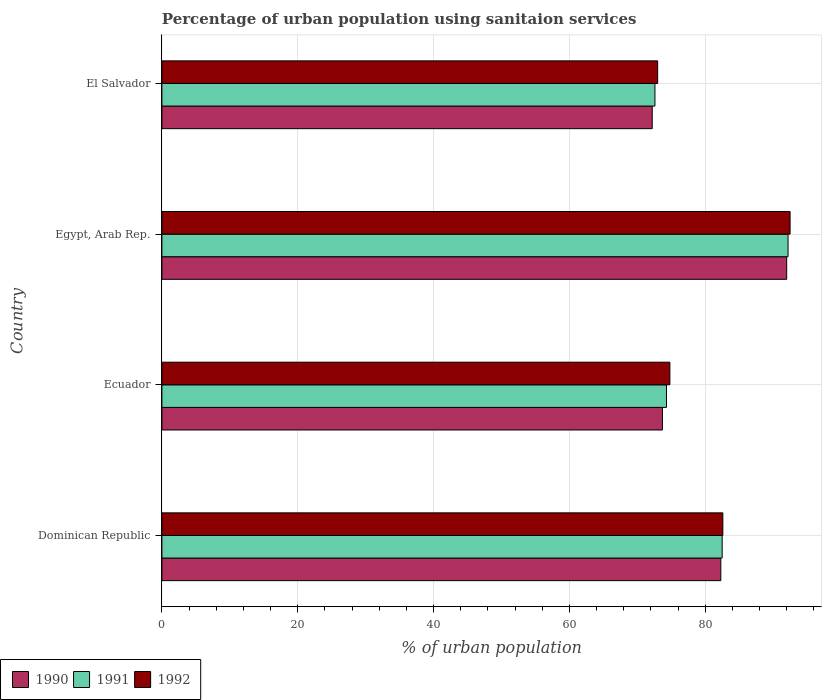How many bars are there on the 2nd tick from the bottom?
Your answer should be compact. 3. What is the label of the 4th group of bars from the top?
Offer a very short reply. Dominican Republic. What is the percentage of urban population using sanitaion services in 1992 in Egypt, Arab Rep.?
Ensure brevity in your answer.  92.5. Across all countries, what is the maximum percentage of urban population using sanitaion services in 1992?
Provide a succinct answer. 92.5. Across all countries, what is the minimum percentage of urban population using sanitaion services in 1990?
Make the answer very short. 72.2. In which country was the percentage of urban population using sanitaion services in 1992 maximum?
Offer a very short reply. Egypt, Arab Rep. In which country was the percentage of urban population using sanitaion services in 1992 minimum?
Your answer should be very brief. El Salvador. What is the total percentage of urban population using sanitaion services in 1991 in the graph?
Ensure brevity in your answer.  321.6. What is the difference between the percentage of urban population using sanitaion services in 1992 in Dominican Republic and that in Ecuador?
Ensure brevity in your answer.  7.8. What is the difference between the percentage of urban population using sanitaion services in 1990 in El Salvador and the percentage of urban population using sanitaion services in 1992 in Egypt, Arab Rep.?
Offer a very short reply. -20.3. What is the average percentage of urban population using sanitaion services in 1992 per country?
Your answer should be very brief. 80.72. What is the difference between the percentage of urban population using sanitaion services in 1991 and percentage of urban population using sanitaion services in 1990 in El Salvador?
Provide a succinct answer. 0.4. In how many countries, is the percentage of urban population using sanitaion services in 1992 greater than 28 %?
Provide a short and direct response. 4. What is the ratio of the percentage of urban population using sanitaion services in 1991 in Dominican Republic to that in Ecuador?
Your response must be concise. 1.11. What is the difference between the highest and the second highest percentage of urban population using sanitaion services in 1990?
Make the answer very short. 9.7. What is the difference between the highest and the lowest percentage of urban population using sanitaion services in 1992?
Offer a very short reply. 19.5. Is the sum of the percentage of urban population using sanitaion services in 1990 in Dominican Republic and Ecuador greater than the maximum percentage of urban population using sanitaion services in 1992 across all countries?
Your response must be concise. Yes. What does the 3rd bar from the bottom in El Salvador represents?
Give a very brief answer. 1992. Is it the case that in every country, the sum of the percentage of urban population using sanitaion services in 1990 and percentage of urban population using sanitaion services in 1992 is greater than the percentage of urban population using sanitaion services in 1991?
Provide a succinct answer. Yes. How many bars are there?
Your response must be concise. 12. What is the difference between two consecutive major ticks on the X-axis?
Your answer should be compact. 20. Are the values on the major ticks of X-axis written in scientific E-notation?
Make the answer very short. No. Where does the legend appear in the graph?
Your answer should be compact. Bottom left. How many legend labels are there?
Offer a very short reply. 3. What is the title of the graph?
Make the answer very short. Percentage of urban population using sanitaion services. Does "2007" appear as one of the legend labels in the graph?
Offer a terse response. No. What is the label or title of the X-axis?
Offer a terse response. % of urban population. What is the label or title of the Y-axis?
Your answer should be compact. Country. What is the % of urban population of 1990 in Dominican Republic?
Your answer should be very brief. 82.3. What is the % of urban population of 1991 in Dominican Republic?
Ensure brevity in your answer.  82.5. What is the % of urban population in 1992 in Dominican Republic?
Make the answer very short. 82.6. What is the % of urban population of 1990 in Ecuador?
Keep it short and to the point. 73.7. What is the % of urban population of 1991 in Ecuador?
Ensure brevity in your answer.  74.3. What is the % of urban population of 1992 in Ecuador?
Give a very brief answer. 74.8. What is the % of urban population in 1990 in Egypt, Arab Rep.?
Keep it short and to the point. 92. What is the % of urban population of 1991 in Egypt, Arab Rep.?
Keep it short and to the point. 92.2. What is the % of urban population in 1992 in Egypt, Arab Rep.?
Give a very brief answer. 92.5. What is the % of urban population of 1990 in El Salvador?
Give a very brief answer. 72.2. What is the % of urban population of 1991 in El Salvador?
Keep it short and to the point. 72.6. Across all countries, what is the maximum % of urban population in 1990?
Your answer should be very brief. 92. Across all countries, what is the maximum % of urban population of 1991?
Provide a succinct answer. 92.2. Across all countries, what is the maximum % of urban population in 1992?
Make the answer very short. 92.5. Across all countries, what is the minimum % of urban population of 1990?
Keep it short and to the point. 72.2. Across all countries, what is the minimum % of urban population in 1991?
Make the answer very short. 72.6. What is the total % of urban population of 1990 in the graph?
Your answer should be very brief. 320.2. What is the total % of urban population in 1991 in the graph?
Make the answer very short. 321.6. What is the total % of urban population of 1992 in the graph?
Your answer should be compact. 322.9. What is the difference between the % of urban population of 1991 in Dominican Republic and that in Ecuador?
Ensure brevity in your answer.  8.2. What is the difference between the % of urban population of 1990 in Dominican Republic and that in Egypt, Arab Rep.?
Your answer should be very brief. -9.7. What is the difference between the % of urban population of 1990 in Dominican Republic and that in El Salvador?
Ensure brevity in your answer.  10.1. What is the difference between the % of urban population of 1991 in Dominican Republic and that in El Salvador?
Make the answer very short. 9.9. What is the difference between the % of urban population of 1992 in Dominican Republic and that in El Salvador?
Offer a very short reply. 9.6. What is the difference between the % of urban population in 1990 in Ecuador and that in Egypt, Arab Rep.?
Give a very brief answer. -18.3. What is the difference between the % of urban population in 1991 in Ecuador and that in Egypt, Arab Rep.?
Provide a succinct answer. -17.9. What is the difference between the % of urban population of 1992 in Ecuador and that in Egypt, Arab Rep.?
Give a very brief answer. -17.7. What is the difference between the % of urban population in 1990 in Ecuador and that in El Salvador?
Give a very brief answer. 1.5. What is the difference between the % of urban population in 1990 in Egypt, Arab Rep. and that in El Salvador?
Offer a very short reply. 19.8. What is the difference between the % of urban population of 1991 in Egypt, Arab Rep. and that in El Salvador?
Keep it short and to the point. 19.6. What is the difference between the % of urban population in 1992 in Egypt, Arab Rep. and that in El Salvador?
Your answer should be compact. 19.5. What is the difference between the % of urban population in 1990 in Dominican Republic and the % of urban population in 1991 in Ecuador?
Offer a very short reply. 8. What is the difference between the % of urban population in 1990 in Dominican Republic and the % of urban population in 1992 in Ecuador?
Your response must be concise. 7.5. What is the difference between the % of urban population of 1991 in Dominican Republic and the % of urban population of 1992 in Ecuador?
Give a very brief answer. 7.7. What is the difference between the % of urban population of 1990 in Dominican Republic and the % of urban population of 1991 in Egypt, Arab Rep.?
Make the answer very short. -9.9. What is the difference between the % of urban population in 1991 in Dominican Republic and the % of urban population in 1992 in Egypt, Arab Rep.?
Offer a very short reply. -10. What is the difference between the % of urban population in 1990 in Dominican Republic and the % of urban population in 1992 in El Salvador?
Ensure brevity in your answer.  9.3. What is the difference between the % of urban population of 1990 in Ecuador and the % of urban population of 1991 in Egypt, Arab Rep.?
Make the answer very short. -18.5. What is the difference between the % of urban population of 1990 in Ecuador and the % of urban population of 1992 in Egypt, Arab Rep.?
Ensure brevity in your answer.  -18.8. What is the difference between the % of urban population of 1991 in Ecuador and the % of urban population of 1992 in Egypt, Arab Rep.?
Provide a succinct answer. -18.2. What is the difference between the % of urban population of 1991 in Ecuador and the % of urban population of 1992 in El Salvador?
Provide a succinct answer. 1.3. What is the difference between the % of urban population in 1990 in Egypt, Arab Rep. and the % of urban population in 1991 in El Salvador?
Your response must be concise. 19.4. What is the difference between the % of urban population in 1991 in Egypt, Arab Rep. and the % of urban population in 1992 in El Salvador?
Offer a very short reply. 19.2. What is the average % of urban population in 1990 per country?
Offer a very short reply. 80.05. What is the average % of urban population of 1991 per country?
Keep it short and to the point. 80.4. What is the average % of urban population of 1992 per country?
Your answer should be very brief. 80.72. What is the difference between the % of urban population of 1990 and % of urban population of 1991 in Dominican Republic?
Your answer should be compact. -0.2. What is the difference between the % of urban population in 1991 and % of urban population in 1992 in Dominican Republic?
Offer a very short reply. -0.1. What is the difference between the % of urban population of 1990 and % of urban population of 1991 in Ecuador?
Give a very brief answer. -0.6. What is the difference between the % of urban population in 1990 and % of urban population in 1991 in Egypt, Arab Rep.?
Your answer should be compact. -0.2. What is the difference between the % of urban population of 1990 and % of urban population of 1992 in Egypt, Arab Rep.?
Give a very brief answer. -0.5. What is the ratio of the % of urban population of 1990 in Dominican Republic to that in Ecuador?
Make the answer very short. 1.12. What is the ratio of the % of urban population in 1991 in Dominican Republic to that in Ecuador?
Offer a very short reply. 1.11. What is the ratio of the % of urban population of 1992 in Dominican Republic to that in Ecuador?
Give a very brief answer. 1.1. What is the ratio of the % of urban population of 1990 in Dominican Republic to that in Egypt, Arab Rep.?
Offer a very short reply. 0.89. What is the ratio of the % of urban population of 1991 in Dominican Republic to that in Egypt, Arab Rep.?
Your answer should be compact. 0.89. What is the ratio of the % of urban population of 1992 in Dominican Republic to that in Egypt, Arab Rep.?
Provide a succinct answer. 0.89. What is the ratio of the % of urban population in 1990 in Dominican Republic to that in El Salvador?
Offer a terse response. 1.14. What is the ratio of the % of urban population in 1991 in Dominican Republic to that in El Salvador?
Offer a very short reply. 1.14. What is the ratio of the % of urban population of 1992 in Dominican Republic to that in El Salvador?
Give a very brief answer. 1.13. What is the ratio of the % of urban population in 1990 in Ecuador to that in Egypt, Arab Rep.?
Your response must be concise. 0.8. What is the ratio of the % of urban population of 1991 in Ecuador to that in Egypt, Arab Rep.?
Your answer should be very brief. 0.81. What is the ratio of the % of urban population in 1992 in Ecuador to that in Egypt, Arab Rep.?
Your answer should be compact. 0.81. What is the ratio of the % of urban population in 1990 in Ecuador to that in El Salvador?
Ensure brevity in your answer.  1.02. What is the ratio of the % of urban population in 1991 in Ecuador to that in El Salvador?
Your response must be concise. 1.02. What is the ratio of the % of urban population in 1992 in Ecuador to that in El Salvador?
Your answer should be very brief. 1.02. What is the ratio of the % of urban population of 1990 in Egypt, Arab Rep. to that in El Salvador?
Provide a succinct answer. 1.27. What is the ratio of the % of urban population of 1991 in Egypt, Arab Rep. to that in El Salvador?
Give a very brief answer. 1.27. What is the ratio of the % of urban population in 1992 in Egypt, Arab Rep. to that in El Salvador?
Ensure brevity in your answer.  1.27. What is the difference between the highest and the lowest % of urban population of 1990?
Your answer should be compact. 19.8. What is the difference between the highest and the lowest % of urban population of 1991?
Offer a terse response. 19.6. What is the difference between the highest and the lowest % of urban population in 1992?
Give a very brief answer. 19.5. 